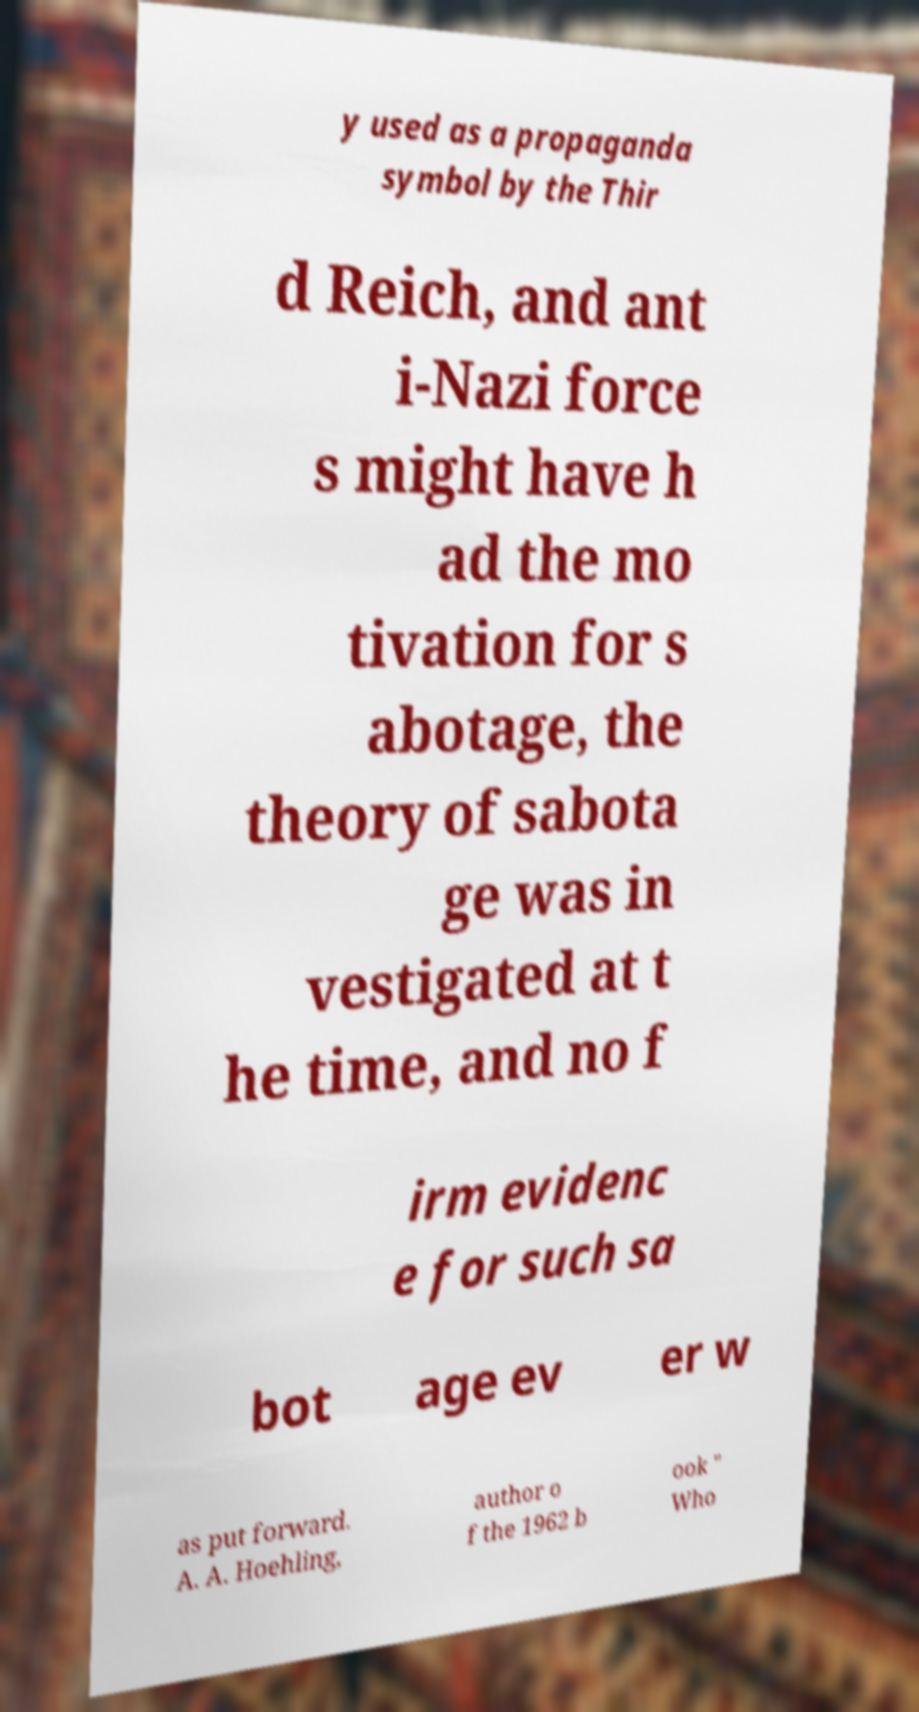Could you assist in decoding the text presented in this image and type it out clearly? y used as a propaganda symbol by the Thir d Reich, and ant i-Nazi force s might have h ad the mo tivation for s abotage, the theory of sabota ge was in vestigated at t he time, and no f irm evidenc e for such sa bot age ev er w as put forward. A. A. Hoehling, author o f the 1962 b ook " Who 